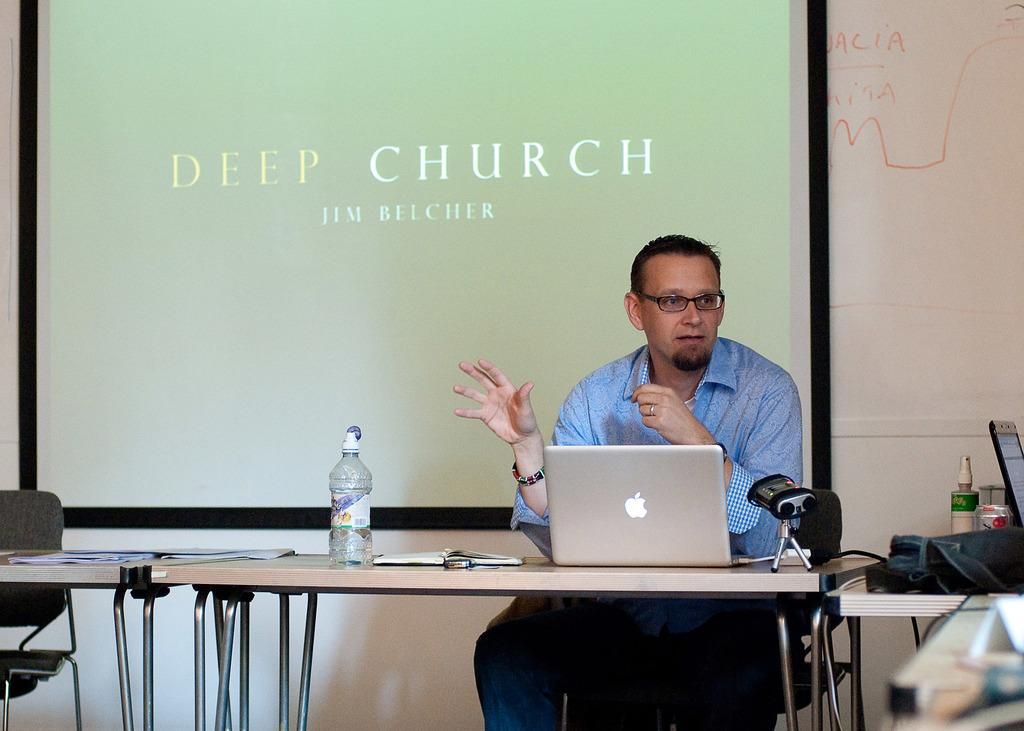What is the person in the image doing? The person is sitting on a chair. What objects are on the table in the image? There is a bottle, a laptop, a book, and papers on the table. What can be seen in the background of the image? There is a wall and a screen in the background. What type of bells can be heard ringing in the image? There are no bells present in the image, and therefore no sound can be heard. What expression is on the person's face in the image? The provided facts do not mention the person's facial expression, so it cannot be determined from the image. 